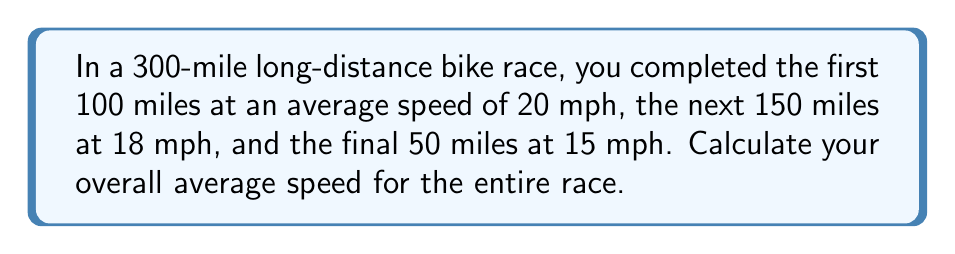Can you solve this math problem? To solve this problem, we need to use the formula:

$$ \text{Average Speed} = \frac{\text{Total Distance}}{\text{Total Time}} $$

Let's break it down step by step:

1) First, calculate the time taken for each segment:
   - Segment 1: $t_1 = \frac{100 \text{ miles}}{20 \text{ mph}} = 5 \text{ hours}$
   - Segment 2: $t_2 = \frac{150 \text{ miles}}{18 \text{ mph}} = 8.33 \text{ hours}$
   - Segment 3: $t_3 = \frac{50 \text{ miles}}{15 \text{ mph}} = 3.33 \text{ hours}$

2) Calculate the total time:
   $$ \text{Total Time} = t_1 + t_2 + t_3 = 5 + 8.33 + 3.33 = 16.66 \text{ hours} $$

3) We know the total distance is 300 miles.

4) Now, apply the average speed formula:
   $$ \text{Average Speed} = \frac{300 \text{ miles}}{16.66 \text{ hours}} = 18.01 \text{ mph} $$

5) Round to two decimal places: 18.01 mph
Answer: 18.01 mph 